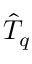Convert formula to latex. <formula><loc_0><loc_0><loc_500><loc_500>\hat { T } _ { q }</formula> 